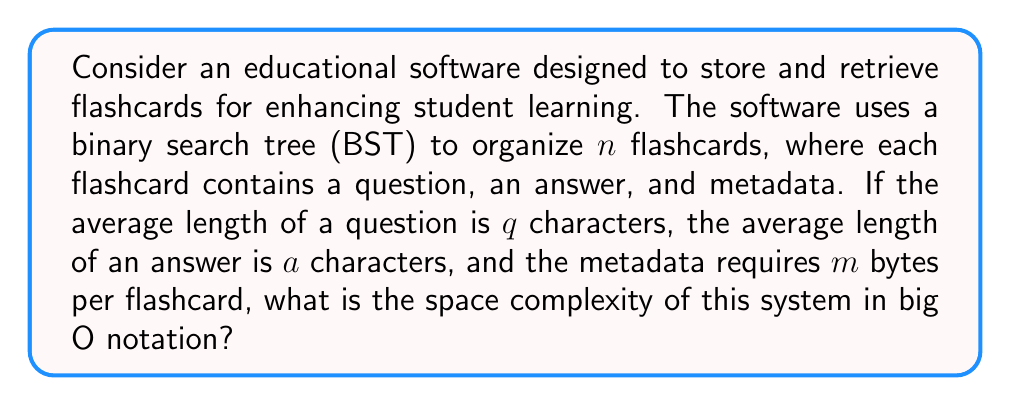Can you answer this question? To evaluate the space complexity of this educational software, we need to consider the storage requirements for the flashcards and the BST structure:

1. Flashcard content:
   - Each flashcard contains a question, an answer, and metadata.
   - Space for question: $O(q)$
   - Space for answer: $O(a)$
   - Space for metadata: $O(m)$
   - Total space per flashcard: $O(q + a + m)$

2. Binary Search Tree structure:
   - A BST with $n$ nodes requires $O(n)$ space for the node structures.
   - Each node contains pointers to left and right children, typically requiring $O(1)$ space each.

3. Total space complexity:
   - For $n$ flashcards: $O(n(q + a + m))$ for the content
   - Plus $O(n)$ for the BST structure
   - Combining these: $O(n(q + a + m) + n)$

4. Simplifying:
   - $O(n(q + a + m) + n)$ simplifies to $O(n(q + a + m))$
   - This is because the $+n$ term is dominated by the $n(q + a + m)$ term for large $n$

5. Final analysis:
   - In big O notation, we typically express complexity in terms of the input size $n$.
   - $q$, $a$, and $m$ are considered constants as they don't grow with $n$.
   - Therefore, we can further simplify to $O(n)$

This analysis shows that the space complexity grows linearly with the number of flashcards, which is important for educators to understand when considering scalability and resource requirements of educational software.
Answer: $O(n)$, where $n$ is the number of flashcards 